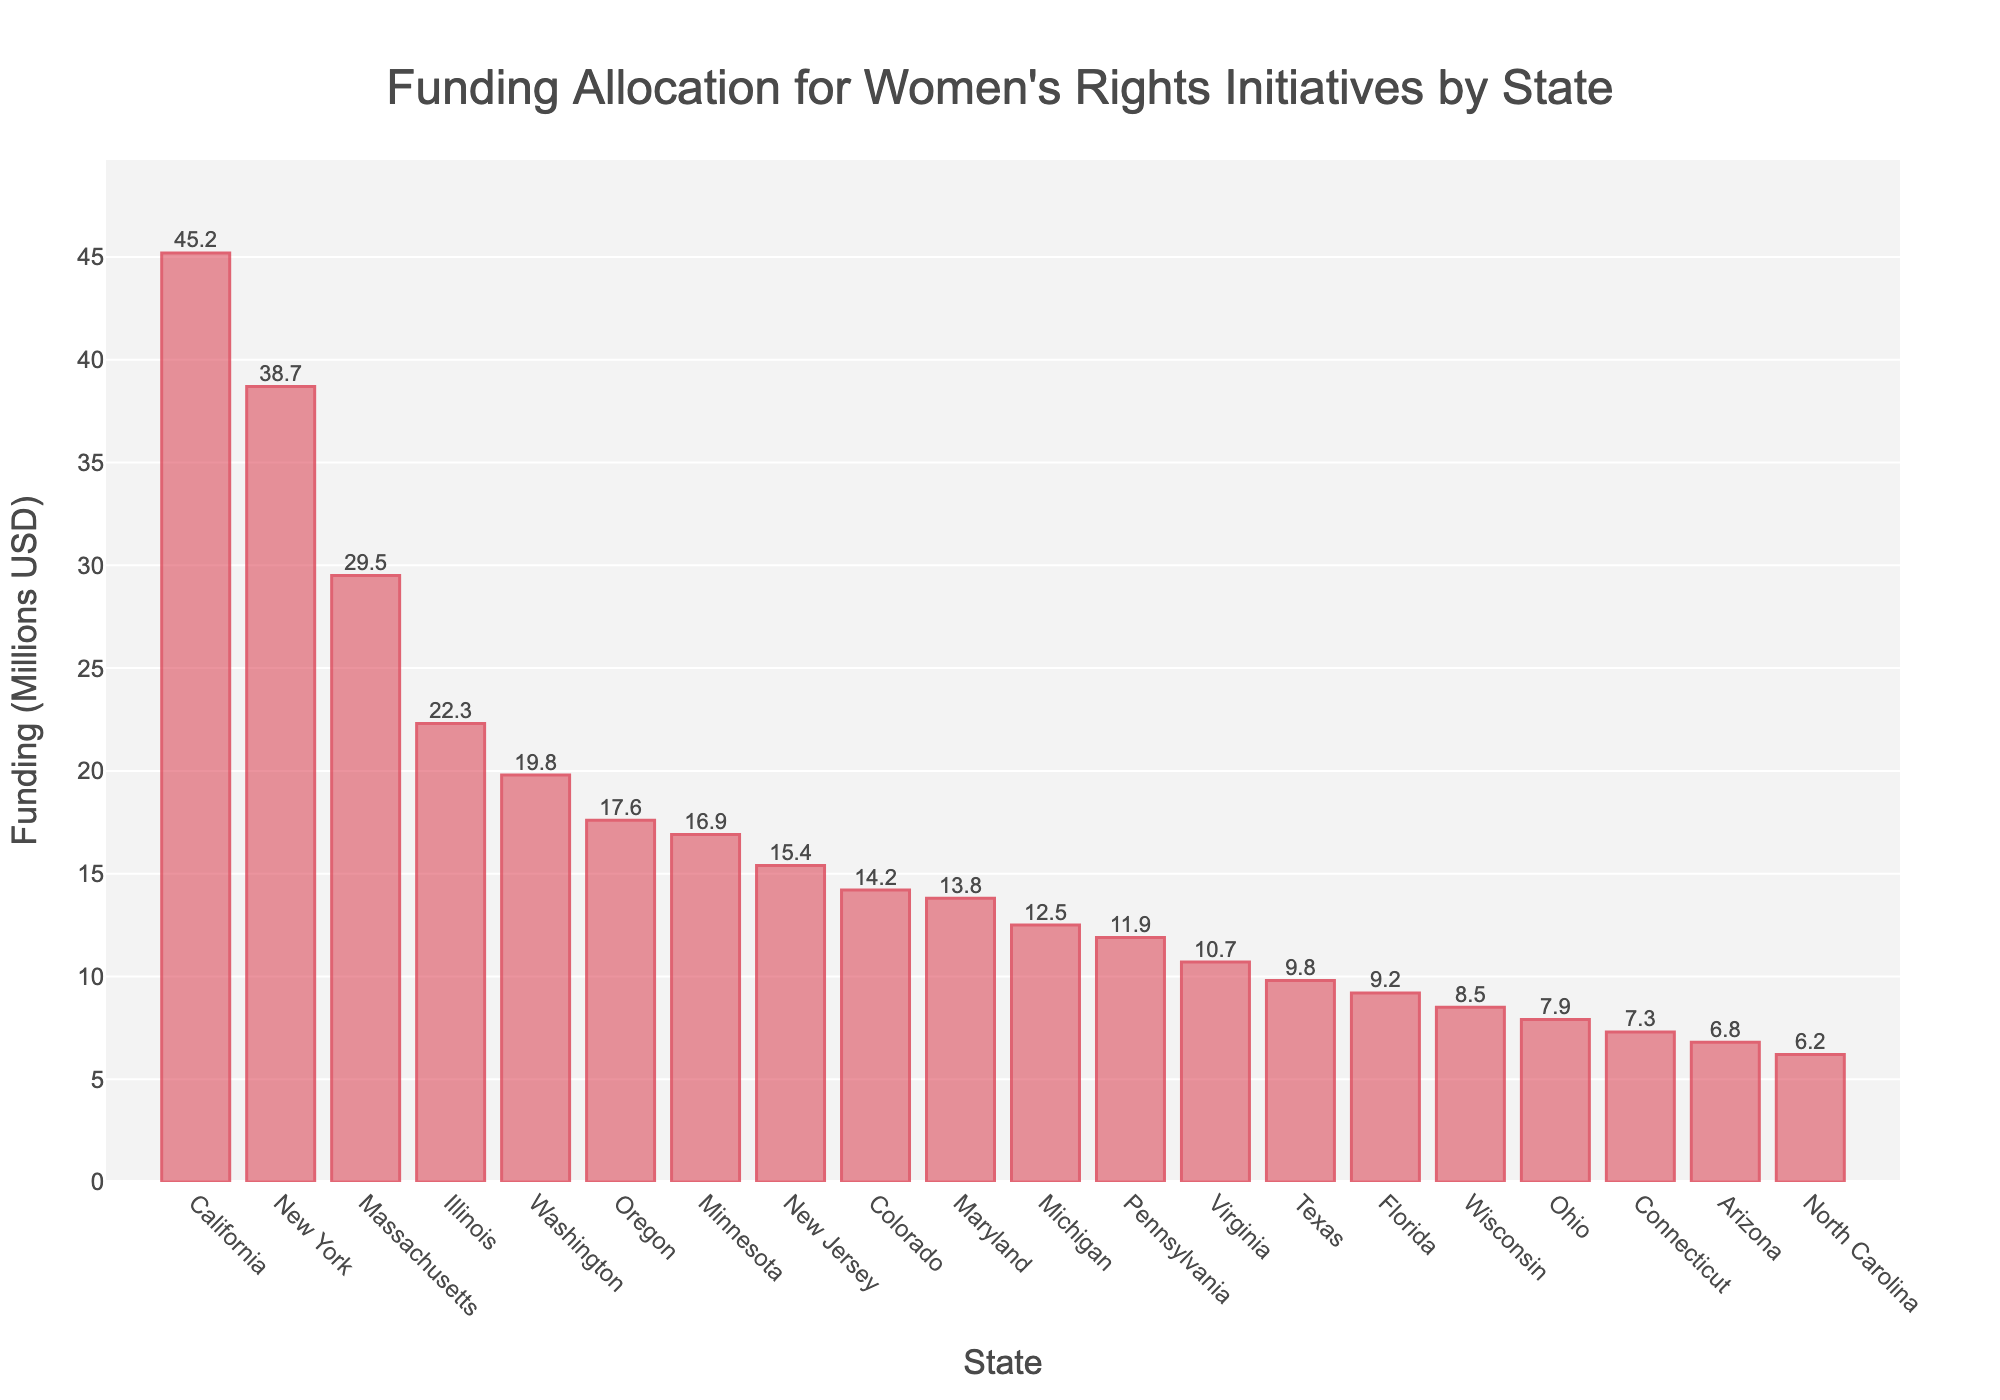Which state has the highest funding allocation? The bar representing California is the tallest, indicating it has the highest funding allocation.
Answer: California What is the difference in funding between California and New York? California has 45.2 million USD and New York has 38.7 million USD. The difference is 45.2 - 38.7 = 6.5 million USD.
Answer: 6.5 million USD Which state has the lowest funding allocation among the listed states? The shortest bar represents North Carolina, indicating it has the lowest funding allocation.
Answer: North Carolina How many states have a funding allocation greater than 20 million USD? By visually inspecting the bars, California, New York, Massachusetts, and Illinois have funding over 20 million USD.
Answer: 4 states What is the average funding allocation for the top three states? The top three states are California (45.2), New York (38.7), and Massachusetts (29.5). Average is (45.2 + 38.7 + 29.5) / 3 = 37.8 million USD.
Answer: 37.8 million USD Which state has a funding allocation closest to 10 million USD? Virginia has a funding allocation of 10.7 million USD, which is the closest to 10 million USD.
Answer: Virginia What is the combined funding allocation for all states with less than 10 million USD in funding? The states are Texas (9.8), Florida (9.2), Wisconsin (8.5), Ohio (7.9), Connecticut (7.3), Arizona (6.8), and North Carolina (6.2). Combined funding is 9.8 + 9.2 + 8.5 + 7.9 + 7.3 + 6.8 + 6.2 = 55.7 million USD.
Answer: 55.7 million USD What is the total funding allocation for all states represented? Summing all given allocations: 45.2 + 38.7 + 29.5 + 22.3 + 19.8 + 17.6 + 16.9 + 15.4 + 14.2 + 13.8 + 12.5 + 11.9 + 10.7 + 9.8 + 9.2 + 8.5 + 7.9 + 7.3 + 6.8 + 6.2 = 318.3 million USD.
Answer: 318.3 million USD Which states have a funding allocation between 10 and 20 million USD? The bars within this range are for Washington, Oregon, Minnesota, New Jersey, Colorado, Maryland, Michigan, Pennsylvania, Virginia.
Answer: Washington, Oregon, Minnesota, New Jersey, Colorado, Maryland, Michigan, Pennsylvania, Virginia How much more funding does California receive than the median state on the plot? The median state in a sorted list is Colorado with 14.2 million USD. California receives 45.2 million USD. The difference is 45.2 - 14.2 = 31 million USD.
Answer: 31 million USD 